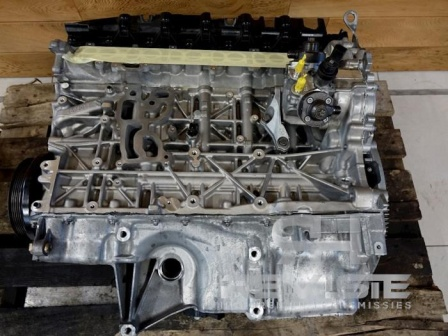Can you explain the importance of these metal pipes and tubes on the engine block? Certainly! The metal pipes and tubes on the engine block play crucial roles in the engine's overall operation. These components are part of various subsystems, including the fuel system, the cooling system, and the air intake system. The pipes involved in the fuel system are responsible for delivering fuel from the tank to the engine, where it is mixed with air and ignited within the cylinders to produce power. The cooling system pipes ensure that coolant circulates around the engine, absorbing excess heat and helping maintain an optimal operating temperature. Lastly, the air intake system pipes guide air into the engine, crucial for the combustion process. Each of these elements must work seamlessly to ensure the engine runs efficiently and reliably. 